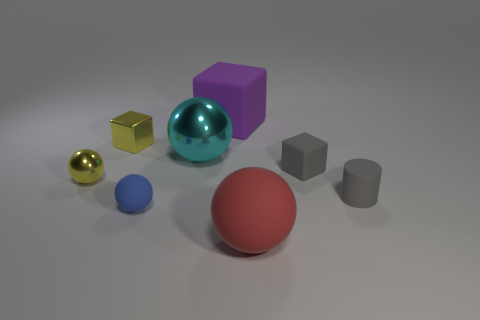There is a small block that is to the right of the large rubber thing that is behind the big rubber sphere; what number of small gray blocks are behind it?
Your response must be concise. 0. There is a sphere that is in front of the cylinder and left of the big purple matte object; what is its material?
Offer a terse response. Rubber. The tiny rubber thing that is both on the right side of the large cyan sphere and left of the cylinder is what color?
Your answer should be very brief. Gray. Are there any other things that have the same color as the small rubber cylinder?
Offer a very short reply. Yes. What is the shape of the small shiny thing behind the shiny ball that is on the left side of the tiny sphere that is to the right of the yellow metallic cube?
Make the answer very short. Cube. What is the color of the small shiny object that is the same shape as the large purple matte object?
Your answer should be very brief. Yellow. The shiny ball that is in front of the large sphere that is left of the red object is what color?
Make the answer very short. Yellow. There is a gray matte thing that is the same shape as the large purple matte object; what is its size?
Provide a succinct answer. Small. How many small yellow things are the same material as the blue thing?
Provide a succinct answer. 0. There is a metallic ball left of the yellow shiny cube; what number of small things are right of it?
Your response must be concise. 4. 